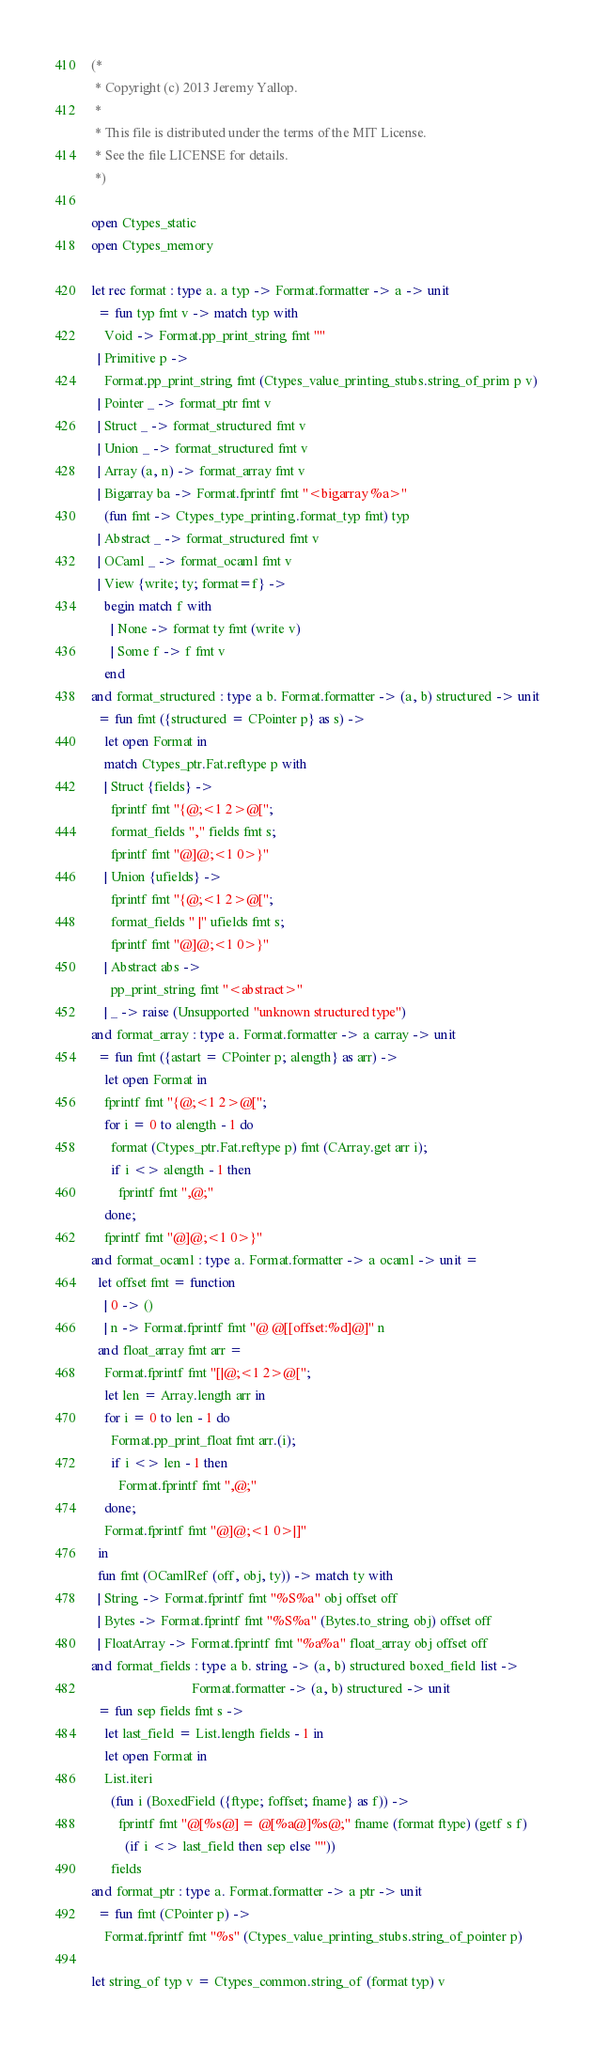Convert code to text. <code><loc_0><loc_0><loc_500><loc_500><_OCaml_>(*
 * Copyright (c) 2013 Jeremy Yallop.
 *
 * This file is distributed under the terms of the MIT License.
 * See the file LICENSE for details.
 *)

open Ctypes_static
open Ctypes_memory

let rec format : type a. a typ -> Format.formatter -> a -> unit
  = fun typ fmt v -> match typ with
    Void -> Format.pp_print_string fmt ""
  | Primitive p ->
    Format.pp_print_string fmt (Ctypes_value_printing_stubs.string_of_prim p v)
  | Pointer _ -> format_ptr fmt v
  | Struct _ -> format_structured fmt v
  | Union _ -> format_structured fmt v
  | Array (a, n) -> format_array fmt v
  | Bigarray ba -> Format.fprintf fmt "<bigarray %a>"
    (fun fmt -> Ctypes_type_printing.format_typ fmt) typ
  | Abstract _ -> format_structured fmt v
  | OCaml _ -> format_ocaml fmt v
  | View {write; ty; format=f} ->
    begin match f with
      | None -> format ty fmt (write v)
      | Some f -> f fmt v
    end
and format_structured : type a b. Format.formatter -> (a, b) structured -> unit
  = fun fmt ({structured = CPointer p} as s) ->
    let open Format in
    match Ctypes_ptr.Fat.reftype p with
    | Struct {fields} ->
      fprintf fmt "{@;<1 2>@[";
      format_fields "," fields fmt s;
      fprintf fmt "@]@;<1 0>}"
    | Union {ufields} ->
      fprintf fmt "{@;<1 2>@[";
      format_fields " |" ufields fmt s;
      fprintf fmt "@]@;<1 0>}"
    | Abstract abs ->
      pp_print_string fmt "<abstract>"
    | _ -> raise (Unsupported "unknown structured type")
and format_array : type a. Format.formatter -> a carray -> unit
  = fun fmt ({astart = CPointer p; alength} as arr) ->
    let open Format in
    fprintf fmt "{@;<1 2>@[";
    for i = 0 to alength - 1 do
      format (Ctypes_ptr.Fat.reftype p) fmt (CArray.get arr i);
      if i <> alength - 1 then
        fprintf fmt ",@;"
    done;
    fprintf fmt "@]@;<1 0>}"
and format_ocaml : type a. Format.formatter -> a ocaml -> unit =
  let offset fmt = function
    | 0 -> ()
    | n -> Format.fprintf fmt "@ @[[offset:%d]@]" n
  and float_array fmt arr =
    Format.fprintf fmt "[|@;<1 2>@[";
    let len = Array.length arr in
    for i = 0 to len - 1 do
      Format.pp_print_float fmt arr.(i);
      if i <> len - 1 then
        Format.fprintf fmt ",@;"
    done;
    Format.fprintf fmt "@]@;<1 0>|]"
  in
  fun fmt (OCamlRef (off, obj, ty)) -> match ty with
  | String -> Format.fprintf fmt "%S%a" obj offset off
  | Bytes -> Format.fprintf fmt "%S%a" (Bytes.to_string obj) offset off
  | FloatArray -> Format.fprintf fmt "%a%a" float_array obj offset off
and format_fields : type a b. string -> (a, b) structured boxed_field list ->
                              Format.formatter -> (a, b) structured -> unit
  = fun sep fields fmt s ->
    let last_field = List.length fields - 1 in
    let open Format in
    List.iteri
      (fun i (BoxedField ({ftype; foffset; fname} as f)) ->
        fprintf fmt "@[%s@] = @[%a@]%s@;" fname (format ftype) (getf s f)
          (if i <> last_field then sep else ""))
      fields
and format_ptr : type a. Format.formatter -> a ptr -> unit
  = fun fmt (CPointer p) ->
    Format.fprintf fmt "%s" (Ctypes_value_printing_stubs.string_of_pointer p)

let string_of typ v = Ctypes_common.string_of (format typ) v
</code> 